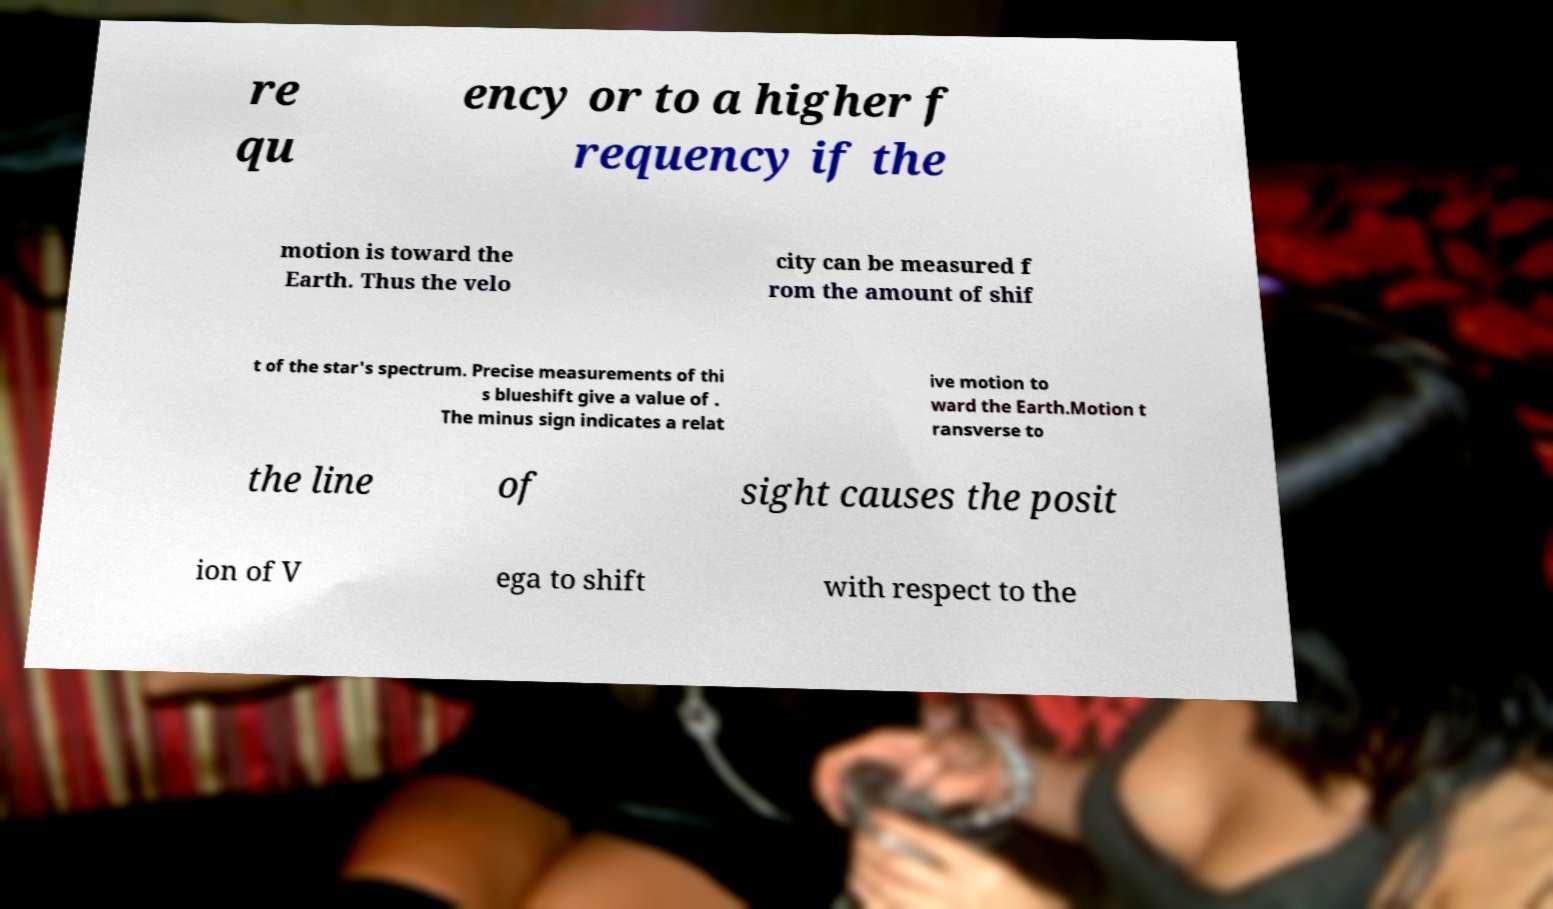I need the written content from this picture converted into text. Can you do that? re qu ency or to a higher f requency if the motion is toward the Earth. Thus the velo city can be measured f rom the amount of shif t of the star's spectrum. Precise measurements of thi s blueshift give a value of . The minus sign indicates a relat ive motion to ward the Earth.Motion t ransverse to the line of sight causes the posit ion of V ega to shift with respect to the 